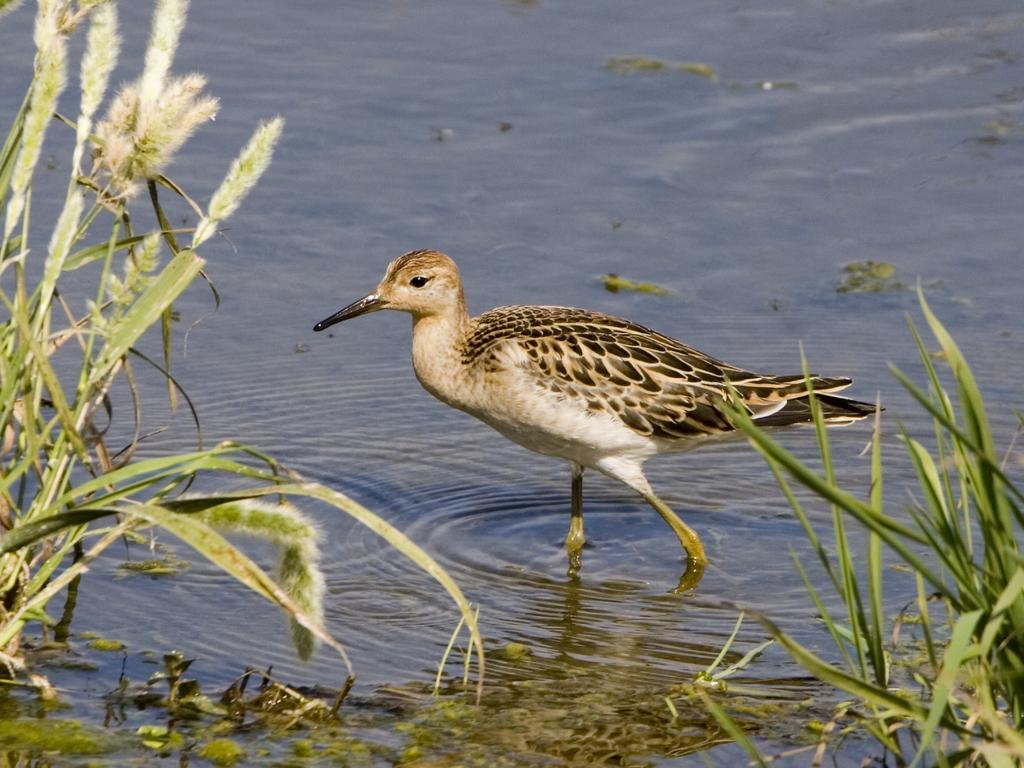What type of bird is in the image? There is a common sandpiper bird in the image. Where is the bird located in the image? The bird is in the water. What type of vegetation is visible beside the bird in the image? There is grass visible beside the bird in the image. What organization is responsible for the bird's habitat in the image? There is no information provided about any organization responsible for the bird's habitat in the image. Is the bird experiencing any pain in the image? There is no indication in the image that the bird is experiencing any pain. 